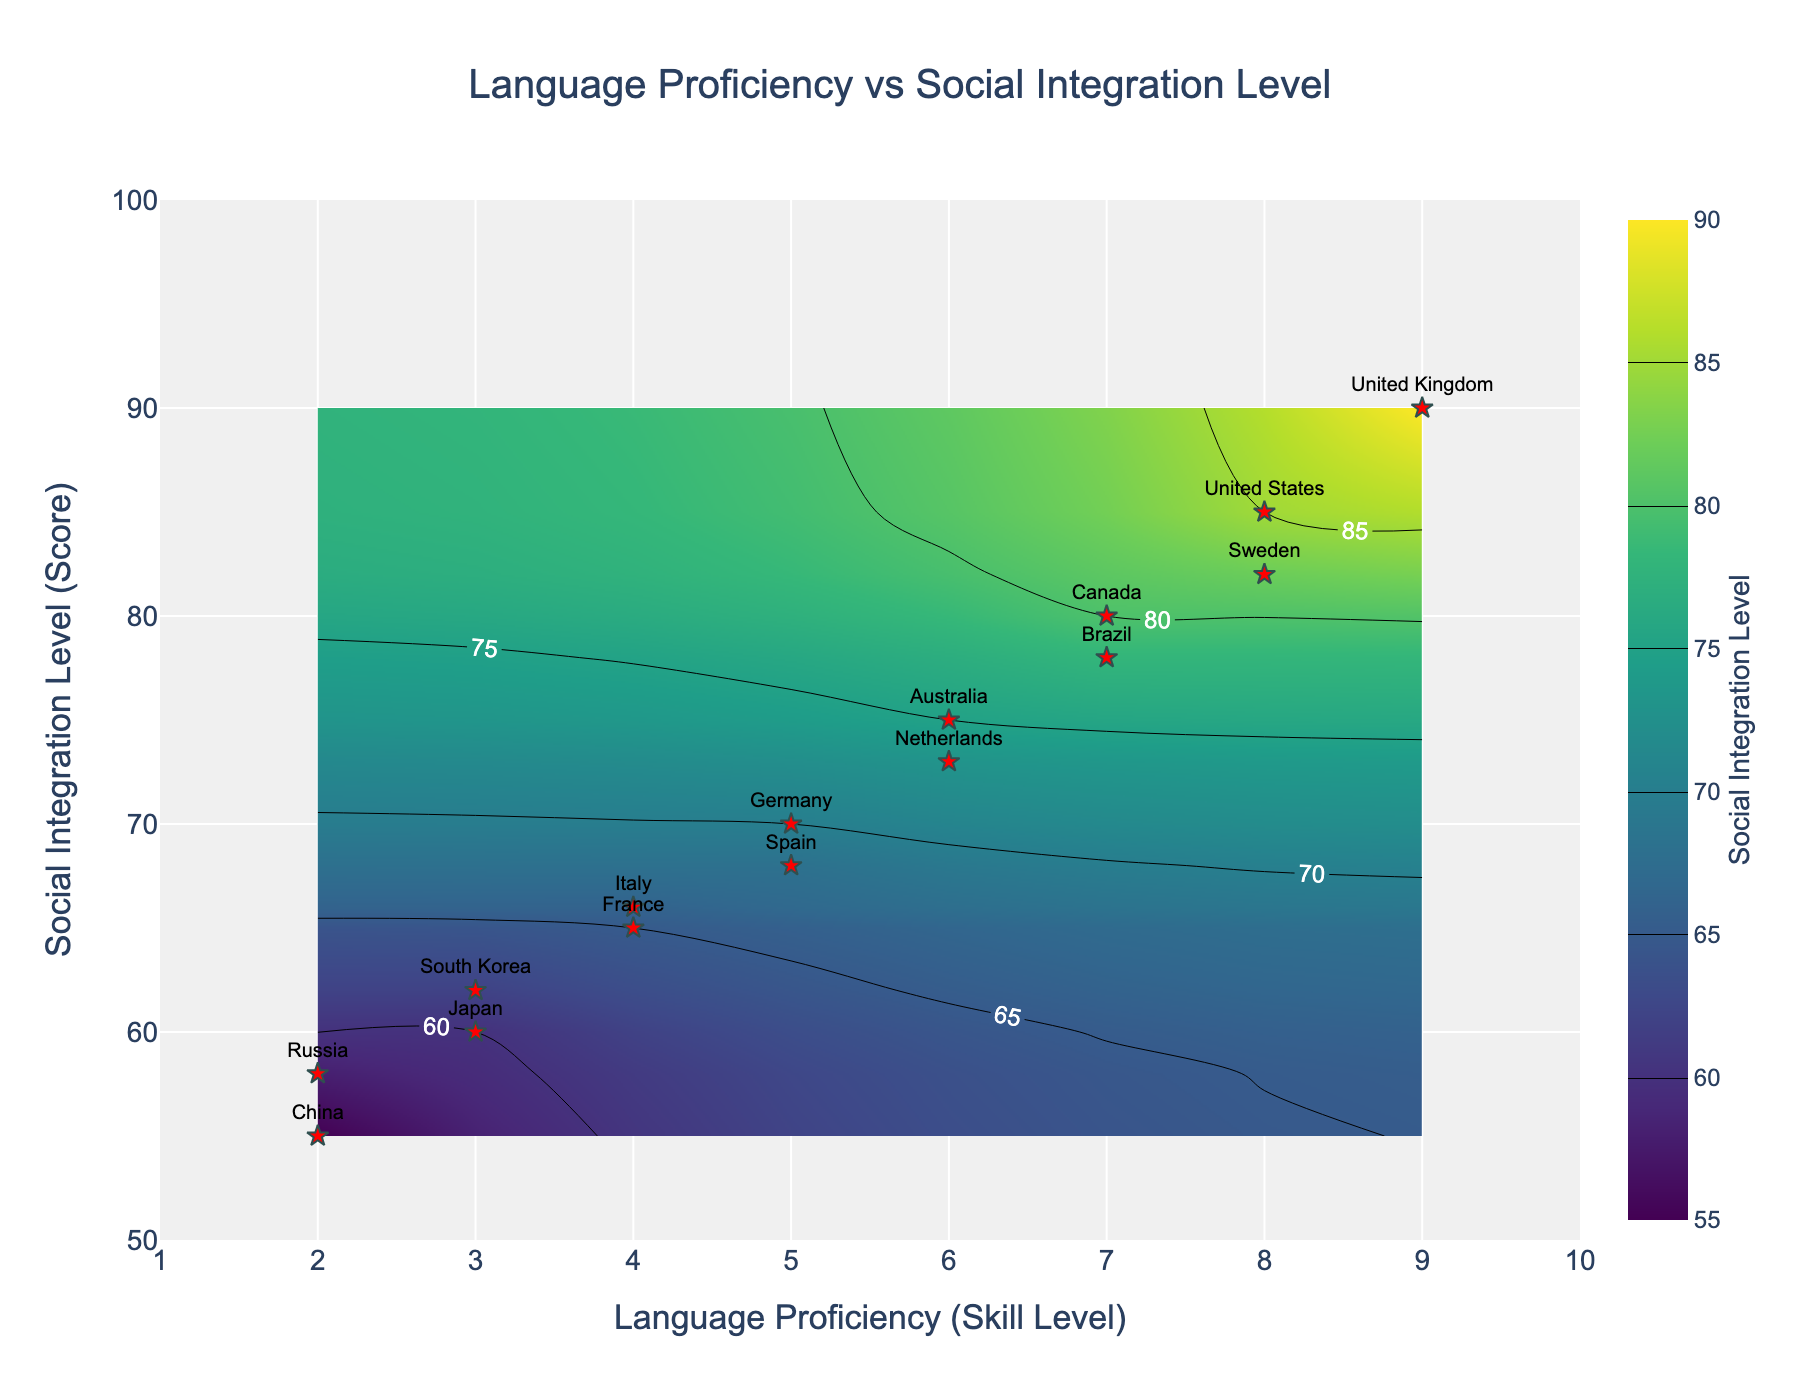How many countries are listed in the scatter plot? Count the number of red star markers in the scatter plot representing different countries. There are 15 markers, so 15 countries are listed.
Answer: 15 What does the color scale in the contour plot represent? The color scale in the contour plot represents the Social Integration Level, as indicated by the color bar title "Social Integration Level" on the right side of the plot.
Answer: Social Integration Level Which country has the highest Language Proficiency? Identify the country with the highest x-axis value (Language Proficiency), which is 9. The country is the United Kingdom.
Answer: United Kingdom What is the Social Integration Level for Japan? Locate Japan on the scatter plot based on labels and check the y-axis value, which corresponds to 60.
Answer: 60 What is the range of the x-axis and y-axis in this contour plot? The x-axis ranges from 1 to 10, and the y-axis ranges from 50 to 100, as shown at the bottom and the left side of the plot, respectively.
Answer: x-axis: 1-10, y-axis: 50-100 How is Sweden's Social Integration Level compared to Canada's? Look at the y-axis positions for Sweden and Canada. Sweden has a Social Integration Level of 82, while Canada has 80. Sweden's Social Integration Level is higher.
Answer: Sweden's is higher What is the lowest Social Integration Level shown on the plot, and which country does it belong to? Identify the minimum y-axis value in the scatter plot, which is 55. This point belongs to China.
Answer: 55, China If you average the Social Integration Levels of countries with a Language Proficiency level of 7, what do you get? Identify that the United States and Canada have a Language Proficiency of 7 with Social Integration Levels of 85 and 80, respectively. Calculate the average: (85 + 80) / 2 = 82.5.
Answer: 82.5 How many countries have a Language Proficiency of 4 or below? Count the countries that have their points at the x-axis value of 4 or below. There are five such countries: France, Italy, Japan, South Korea, and Russia.
Answer: 5 What does the title of this contour plot suggest? Read the plot title "Language Proficiency vs Social Integration Level" that is displayed at the top of the plot. The title suggests it is comparing Language Proficiency against Social Integration Level among different countries.
Answer: Language Proficiency vs Social Integration Level 